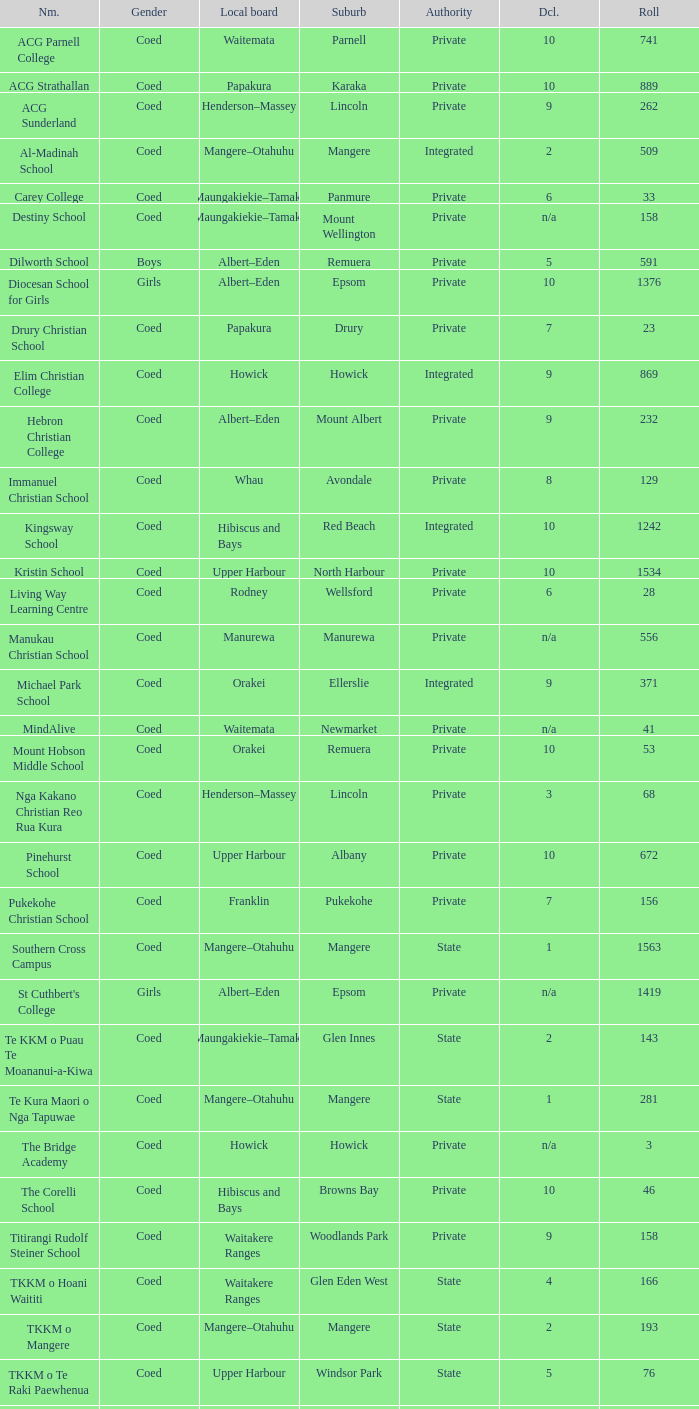Can you parse all the data within this table? {'header': ['Nm.', 'Gender', 'Local board', 'Suburb', 'Authority', 'Dcl.', 'Roll'], 'rows': [['ACG Parnell College', 'Coed', 'Waitemata', 'Parnell', 'Private', '10', '741'], ['ACG Strathallan', 'Coed', 'Papakura', 'Karaka', 'Private', '10', '889'], ['ACG Sunderland', 'Coed', 'Henderson–Massey', 'Lincoln', 'Private', '9', '262'], ['Al-Madinah School', 'Coed', 'Mangere–Otahuhu', 'Mangere', 'Integrated', '2', '509'], ['Carey College', 'Coed', 'Maungakiekie–Tamaki', 'Panmure', 'Private', '6', '33'], ['Destiny School', 'Coed', 'Maungakiekie–Tamaki', 'Mount Wellington', 'Private', 'n/a', '158'], ['Dilworth School', 'Boys', 'Albert–Eden', 'Remuera', 'Private', '5', '591'], ['Diocesan School for Girls', 'Girls', 'Albert–Eden', 'Epsom', 'Private', '10', '1376'], ['Drury Christian School', 'Coed', 'Papakura', 'Drury', 'Private', '7', '23'], ['Elim Christian College', 'Coed', 'Howick', 'Howick', 'Integrated', '9', '869'], ['Hebron Christian College', 'Coed', 'Albert–Eden', 'Mount Albert', 'Private', '9', '232'], ['Immanuel Christian School', 'Coed', 'Whau', 'Avondale', 'Private', '8', '129'], ['Kingsway School', 'Coed', 'Hibiscus and Bays', 'Red Beach', 'Integrated', '10', '1242'], ['Kristin School', 'Coed', 'Upper Harbour', 'North Harbour', 'Private', '10', '1534'], ['Living Way Learning Centre', 'Coed', 'Rodney', 'Wellsford', 'Private', '6', '28'], ['Manukau Christian School', 'Coed', 'Manurewa', 'Manurewa', 'Private', 'n/a', '556'], ['Michael Park School', 'Coed', 'Orakei', 'Ellerslie', 'Integrated', '9', '371'], ['MindAlive', 'Coed', 'Waitemata', 'Newmarket', 'Private', 'n/a', '41'], ['Mount Hobson Middle School', 'Coed', 'Orakei', 'Remuera', 'Private', '10', '53'], ['Nga Kakano Christian Reo Rua Kura', 'Coed', 'Henderson–Massey', 'Lincoln', 'Private', '3', '68'], ['Pinehurst School', 'Coed', 'Upper Harbour', 'Albany', 'Private', '10', '672'], ['Pukekohe Christian School', 'Coed', 'Franklin', 'Pukekohe', 'Private', '7', '156'], ['Southern Cross Campus', 'Coed', 'Mangere–Otahuhu', 'Mangere', 'State', '1', '1563'], ["St Cuthbert's College", 'Girls', 'Albert–Eden', 'Epsom', 'Private', 'n/a', '1419'], ['Te KKM o Puau Te Moananui-a-Kiwa', 'Coed', 'Maungakiekie–Tamaki', 'Glen Innes', 'State', '2', '143'], ['Te Kura Maori o Nga Tapuwae', 'Coed', 'Mangere–Otahuhu', 'Mangere', 'State', '1', '281'], ['The Bridge Academy', 'Coed', 'Howick', 'Howick', 'Private', 'n/a', '3'], ['The Corelli School', 'Coed', 'Hibiscus and Bays', 'Browns Bay', 'Private', '10', '46'], ['Titirangi Rudolf Steiner School', 'Coed', 'Waitakere Ranges', 'Woodlands Park', 'Private', '9', '158'], ['TKKM o Hoani Waititi', 'Coed', 'Waitakere Ranges', 'Glen Eden West', 'State', '4', '166'], ['TKKM o Mangere', 'Coed', 'Mangere–Otahuhu', 'Mangere', 'State', '2', '193'], ['TKKM o Te Raki Paewhenua', 'Coed', 'Upper Harbour', 'Windsor Park', 'State', '5', '76'], ['Tyndale Park Christian School', 'Coed', 'Howick', 'Flat Bush', 'Private', 'n/a', '120']]} What is the name when the local board is albert–eden, and a Decile of 9? Hebron Christian College. 